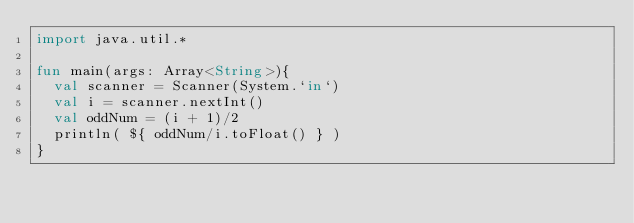<code> <loc_0><loc_0><loc_500><loc_500><_Kotlin_>import java.util.*

fun main(args: Array<String>){
  val scanner = Scanner(System.`in`)
  val i = scanner.nextInt()
  val oddNum = (i + 1)/2
  println( ${ oddNum/i.toFloat() } )
}</code> 